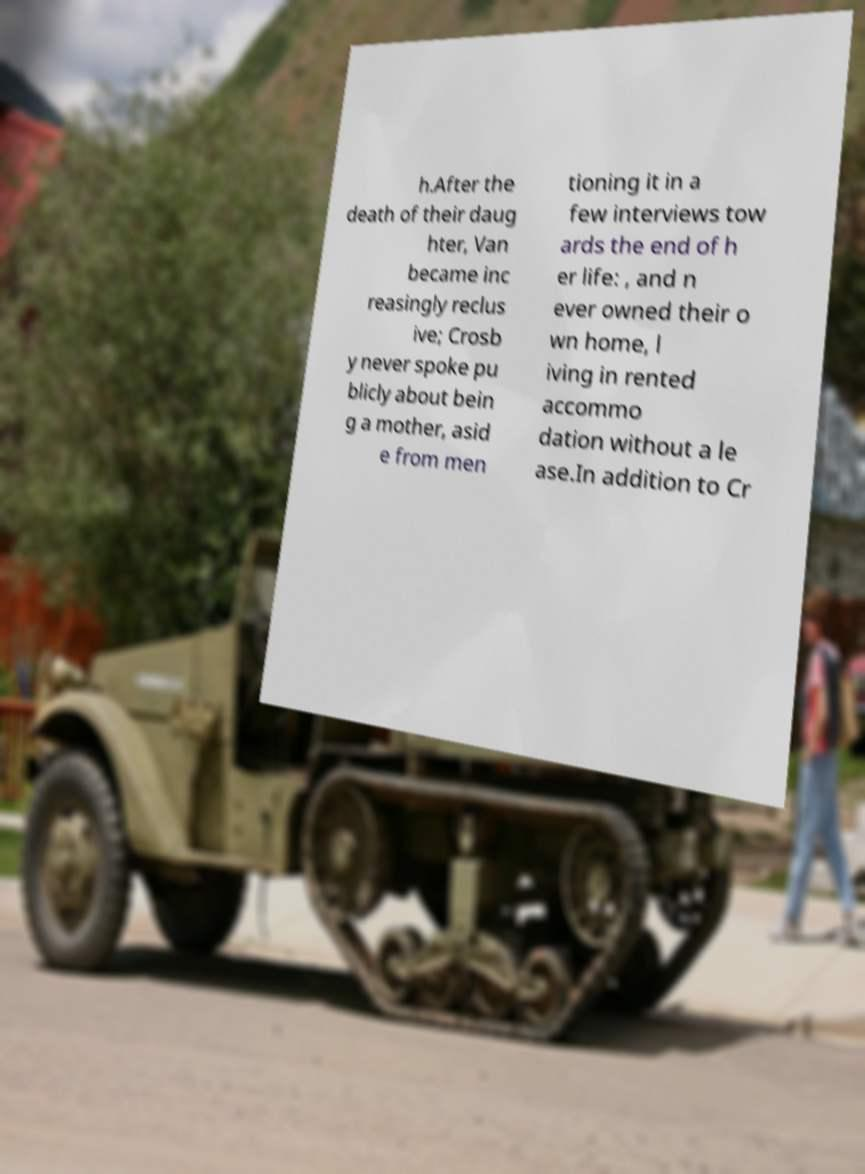Can you read and provide the text displayed in the image?This photo seems to have some interesting text. Can you extract and type it out for me? h.After the death of their daug hter, Van became inc reasingly reclus ive; Crosb y never spoke pu blicly about bein g a mother, asid e from men tioning it in a few interviews tow ards the end of h er life: , and n ever owned their o wn home, l iving in rented accommo dation without a le ase.In addition to Cr 